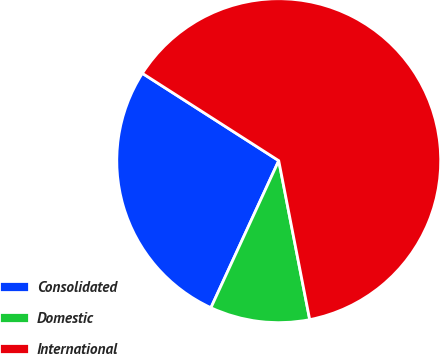Convert chart. <chart><loc_0><loc_0><loc_500><loc_500><pie_chart><fcel>Consolidated<fcel>Domestic<fcel>International<nl><fcel>27.19%<fcel>9.94%<fcel>62.87%<nl></chart> 